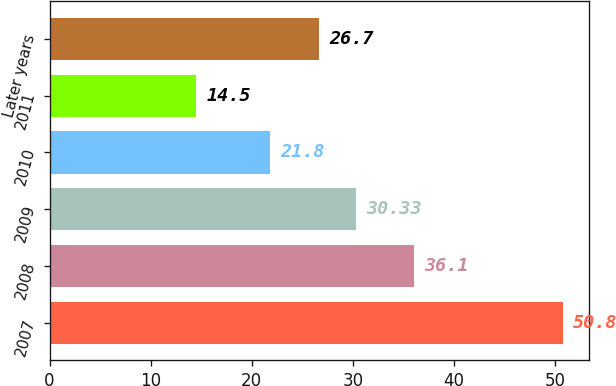Convert chart to OTSL. <chart><loc_0><loc_0><loc_500><loc_500><bar_chart><fcel>2007<fcel>2008<fcel>2009<fcel>2010<fcel>2011<fcel>Later years<nl><fcel>50.8<fcel>36.1<fcel>30.33<fcel>21.8<fcel>14.5<fcel>26.7<nl></chart> 